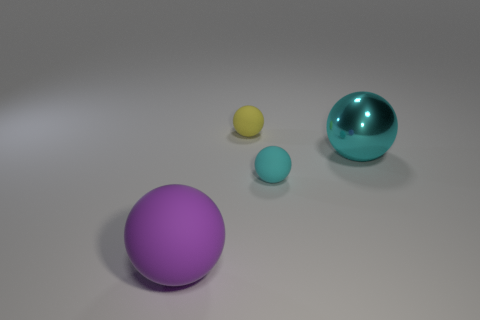How many cyan objects are either metallic spheres or large balls?
Give a very brief answer. 1. There is a sphere that is both left of the tiny cyan sphere and in front of the metallic ball; what size is it?
Ensure brevity in your answer.  Large. Are there more rubber objects that are in front of the small cyan rubber object than small brown things?
Your response must be concise. Yes. What number of balls are purple matte objects or cyan metallic objects?
Keep it short and to the point. 2. There is a object that is behind the large matte ball and in front of the big shiny thing; what is its shape?
Your response must be concise. Sphere. Is the number of big cyan objects that are in front of the large matte thing the same as the number of yellow matte balls behind the cyan metal ball?
Give a very brief answer. No. What number of objects are either matte objects or large metallic balls?
Provide a succinct answer. 4. There is another sphere that is the same size as the yellow rubber sphere; what is its color?
Your response must be concise. Cyan. What number of objects are either matte things right of the purple object or rubber balls that are right of the big purple thing?
Keep it short and to the point. 2. Are there an equal number of cyan shiny balls on the left side of the small cyan object and big brown cylinders?
Keep it short and to the point. Yes. 